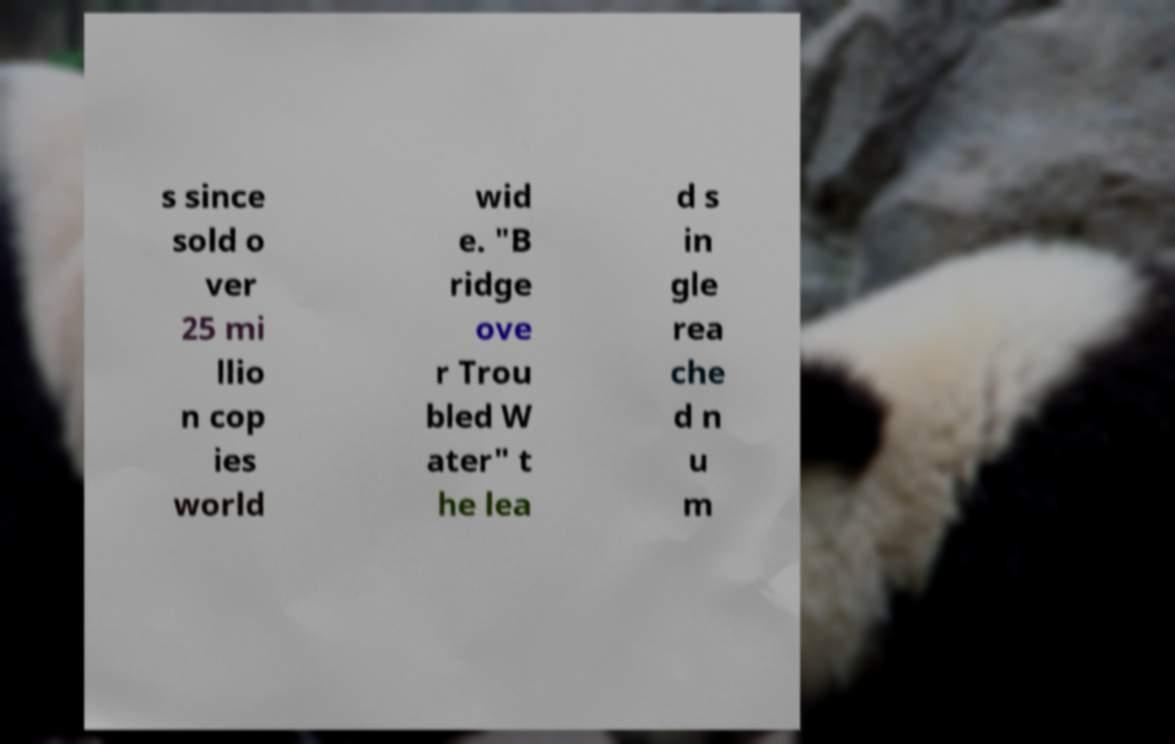Please identify and transcribe the text found in this image. s since sold o ver 25 mi llio n cop ies world wid e. "B ridge ove r Trou bled W ater" t he lea d s in gle rea che d n u m 